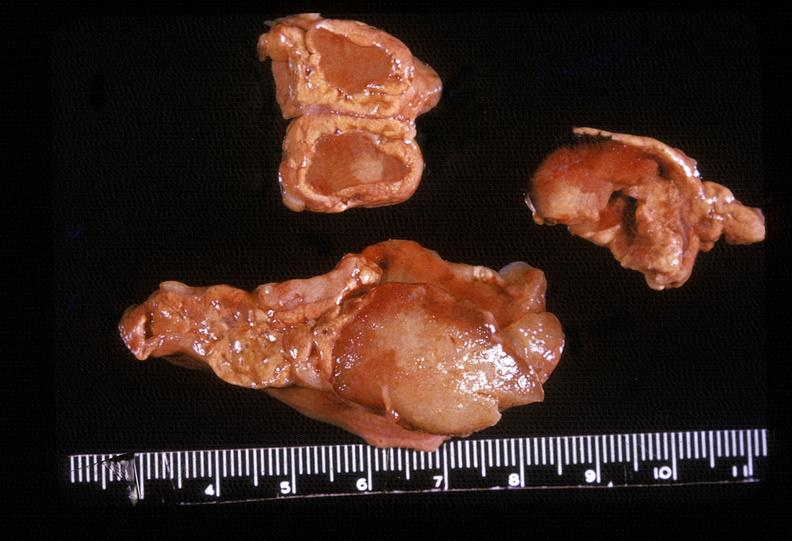does this image show adrenal, myelolipoma?
Answer the question using a single word or phrase. Yes 